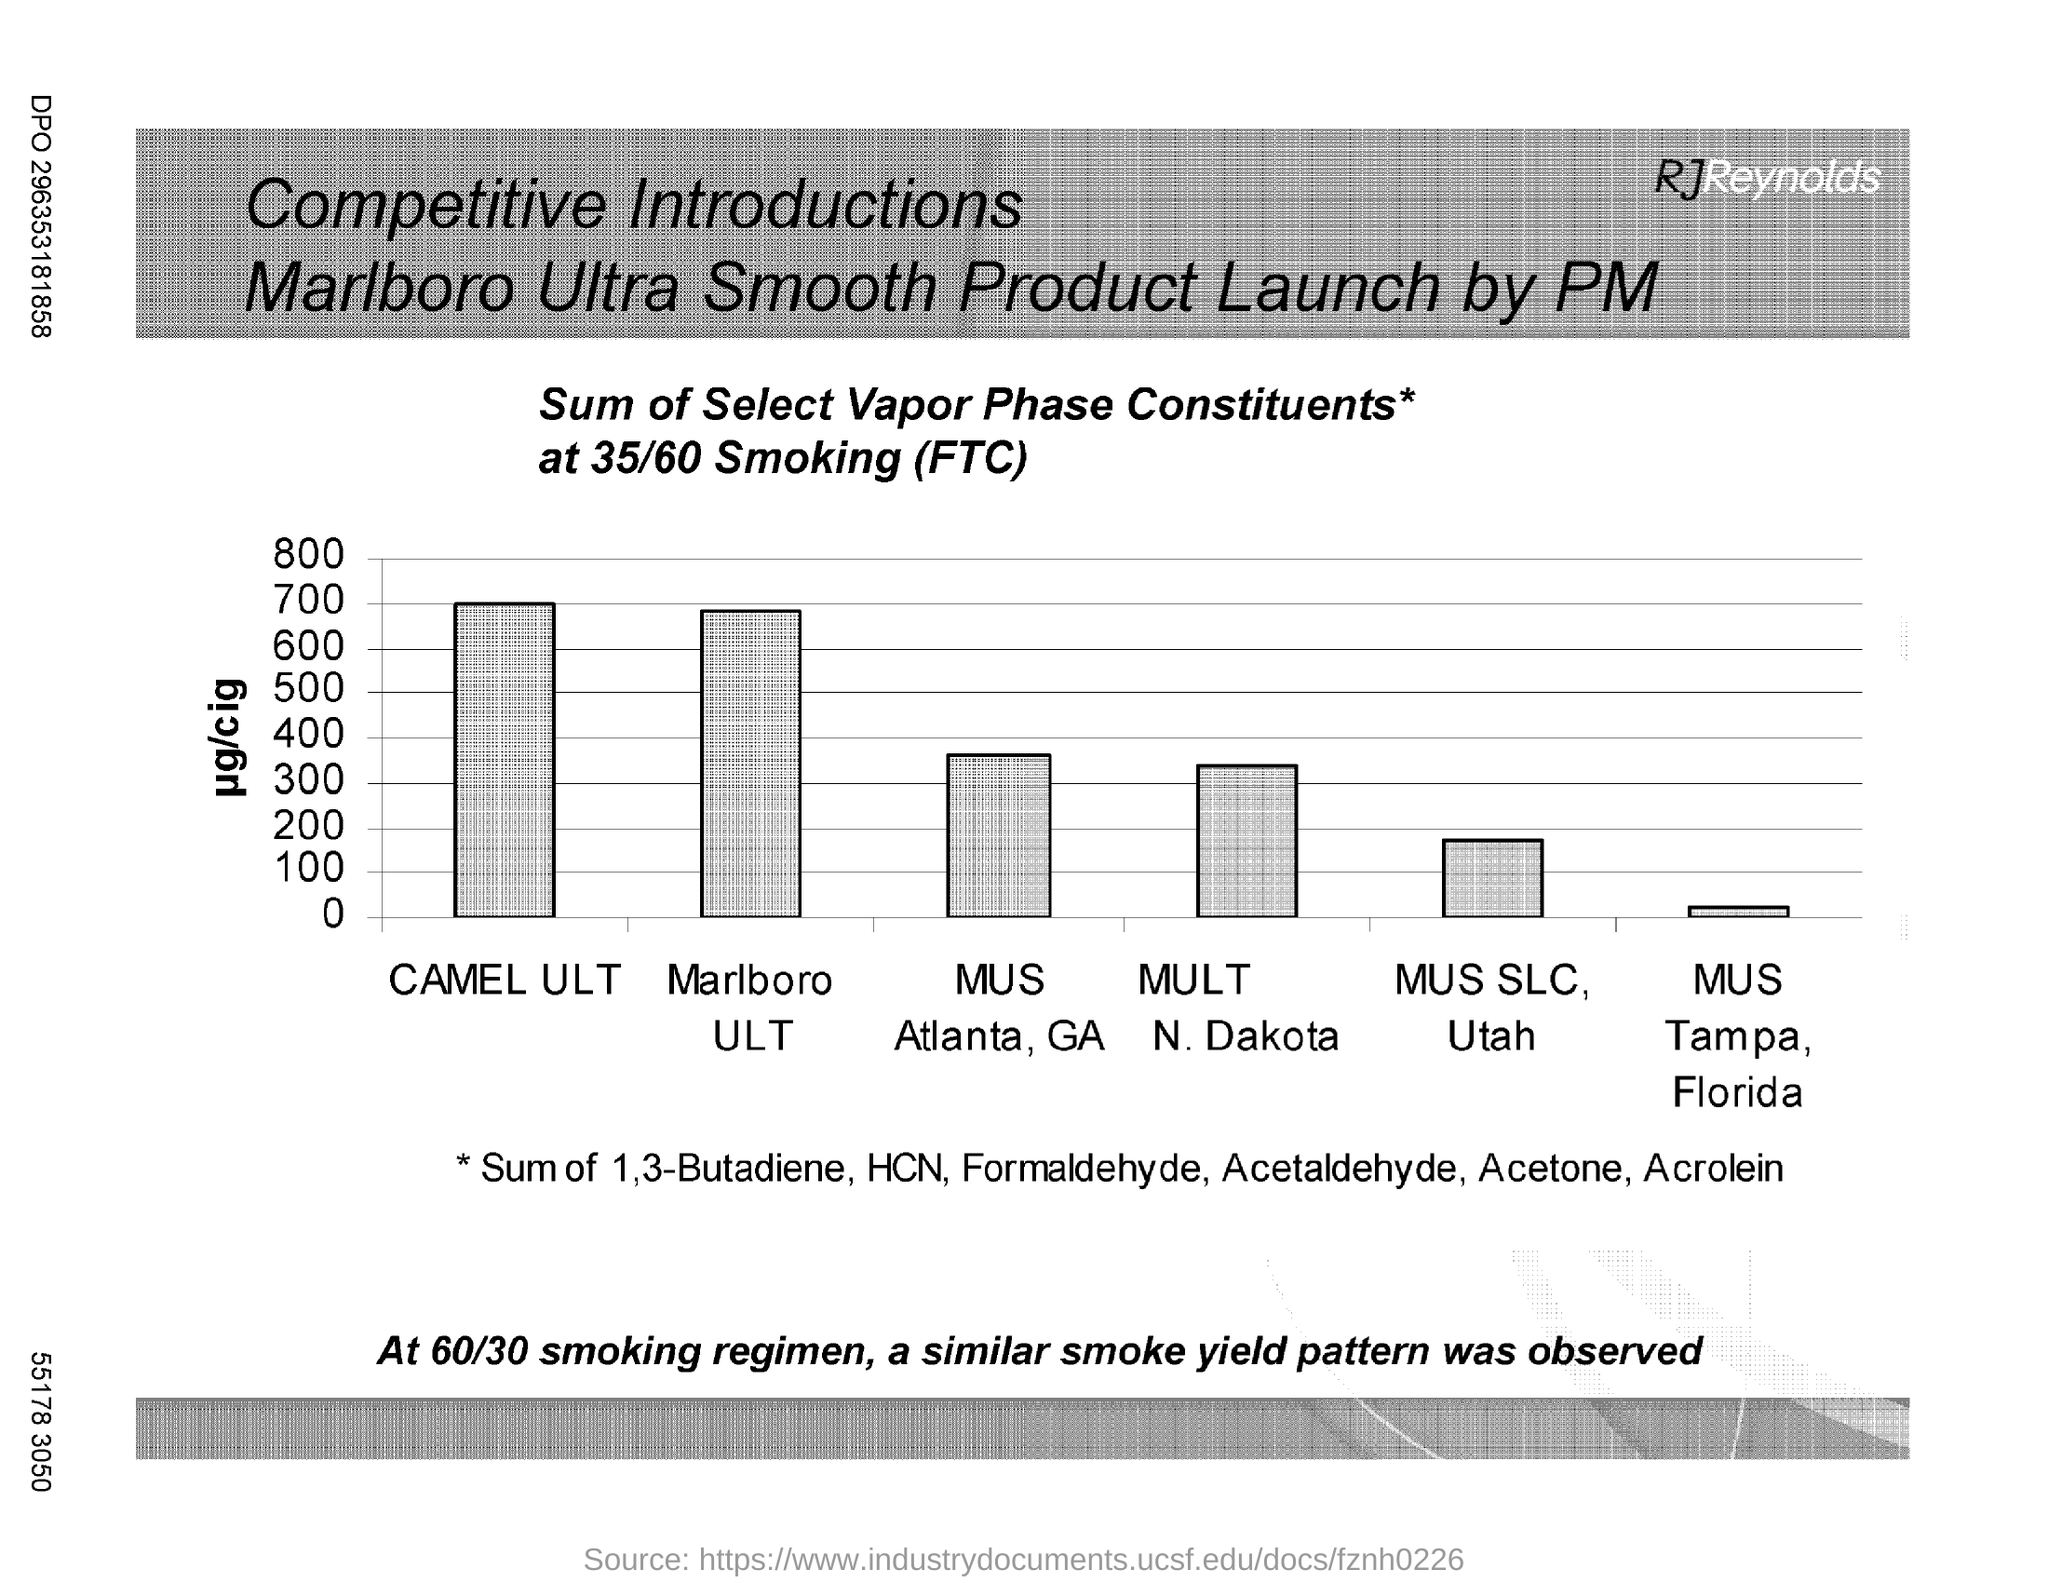What is the value against 'CAMEL ULT' ?
Your answer should be compact. 700. What is the minimum value in Y axis?
Keep it short and to the point. 0. What is the maximum value plotted in Y-axis?
Give a very brief answer. 800. 